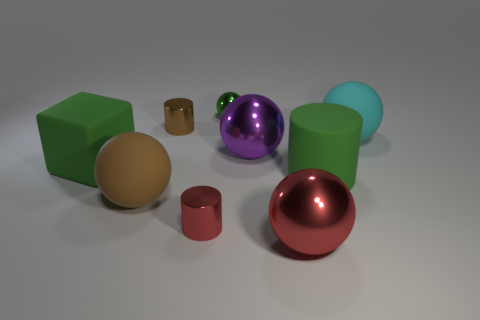There is a tiny cylinder that is behind the big purple metallic ball; are there any metallic cylinders in front of it?
Offer a very short reply. Yes. What color is the matte block that is the same size as the red ball?
Your response must be concise. Green. What number of objects are either red metal cylinders or cubes?
Your answer should be compact. 2. There is a matte block behind the small metal cylinder that is in front of the green rubber object on the right side of the large red metal thing; what size is it?
Keep it short and to the point. Large. What number of balls have the same color as the big cylinder?
Keep it short and to the point. 1. How many objects are made of the same material as the red cylinder?
Make the answer very short. 4. What number of things are either large red metal spheres or tiny brown objects behind the large purple metallic thing?
Offer a terse response. 2. What color is the big matte object that is behind the large green object that is on the left side of the brown object that is behind the cyan rubber thing?
Provide a succinct answer. Cyan. There is a shiny cylinder right of the small brown cylinder; what size is it?
Your answer should be compact. Small. What number of small objects are either yellow metallic cylinders or brown cylinders?
Your response must be concise. 1. 